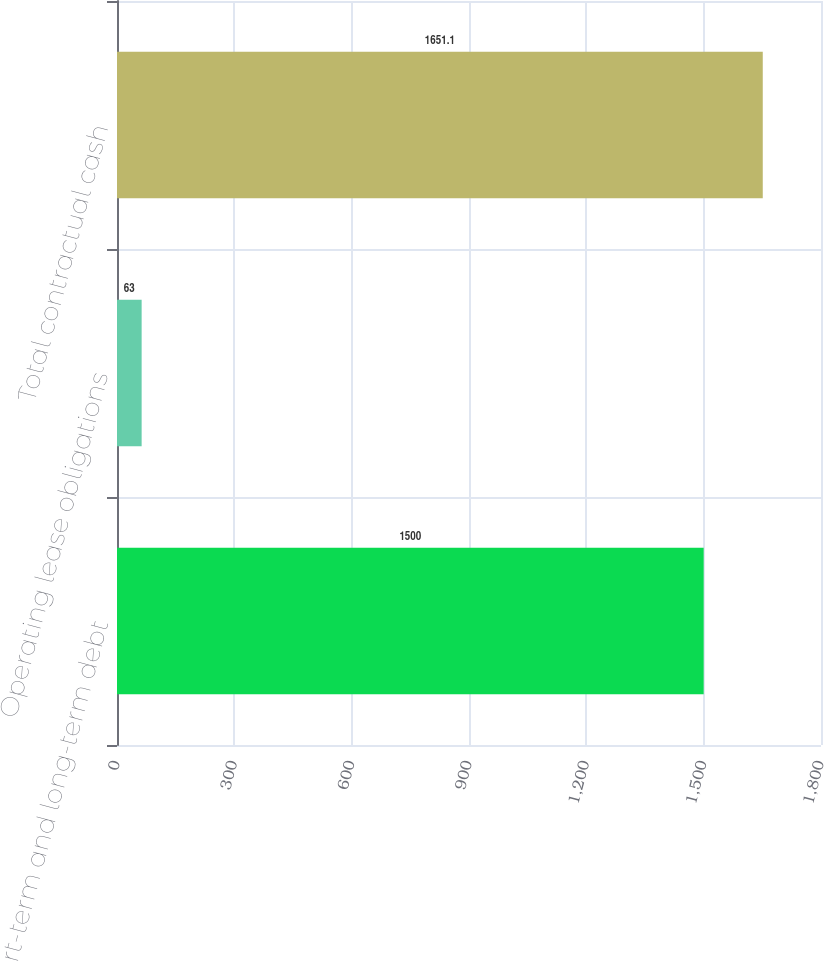Convert chart. <chart><loc_0><loc_0><loc_500><loc_500><bar_chart><fcel>Short-term and long-term debt<fcel>Operating lease obligations<fcel>Total contractual cash<nl><fcel>1500<fcel>63<fcel>1651.1<nl></chart> 